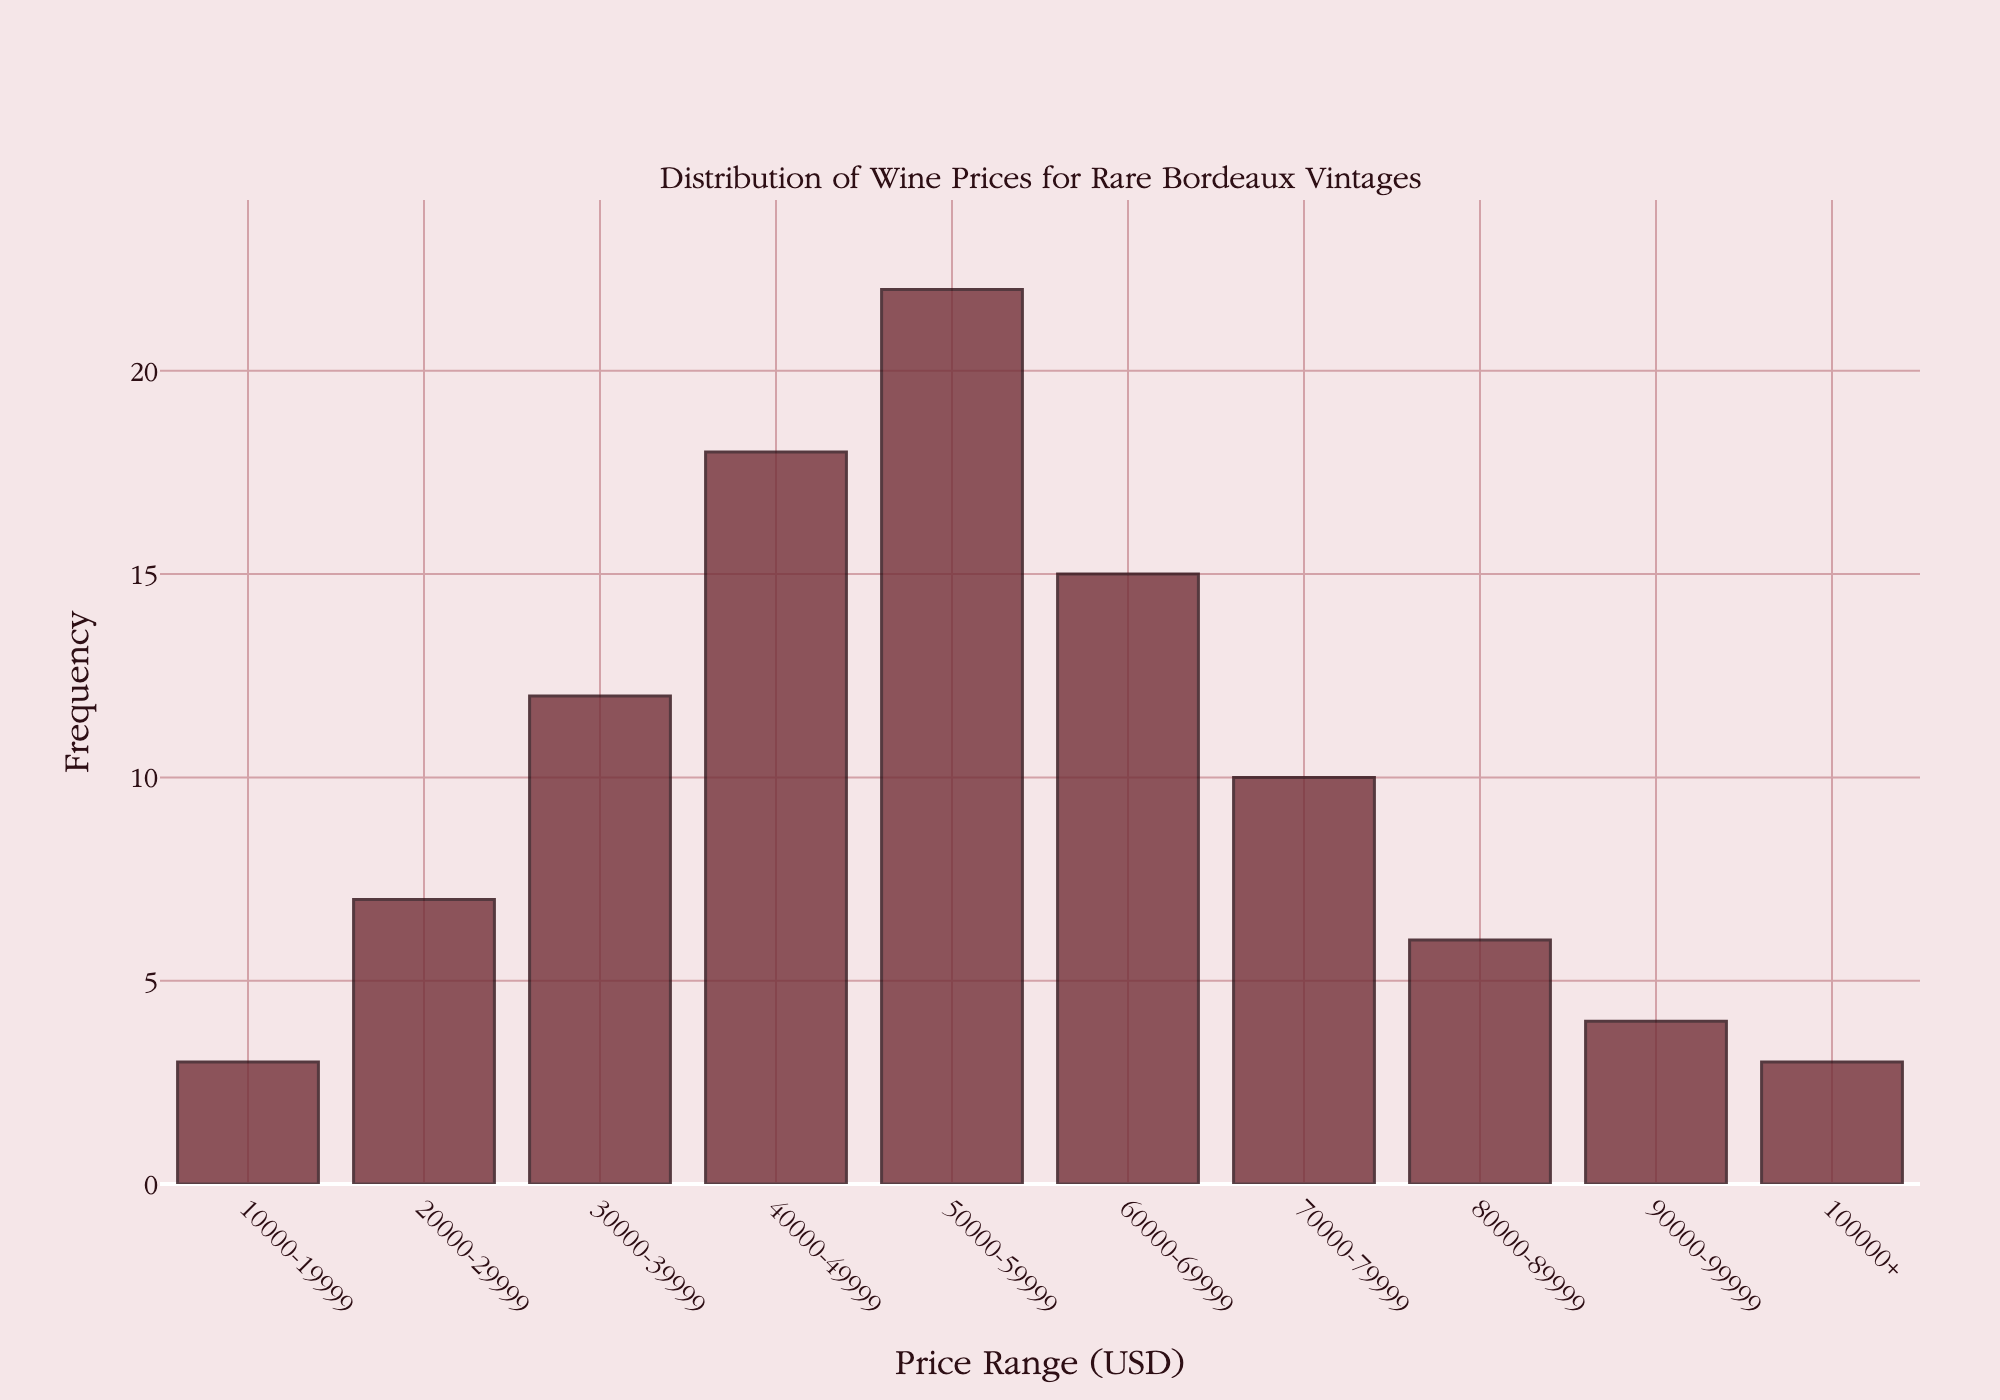What's the color of the bars? By observing the figure, the bars are colored in a deep maroon shade. This is the visual element used to represent the frequency of wine prices.
Answer: Deep maroon What is the title of the plot? The title is located at the top of the plot, and it states the topic or subject of the figure.
Answer: Distribution of Wine Prices for Rare Bordeaux Vintages Which price range has the highest frequency of wines? To find this, scan the bars to identify the tallest one, which represents the range with the highest frequency.
Answer: 50000-59999 How many wines are priced between $70,000 and $79,999? Look at the bar corresponding to the price range $70,000-$79,999 and check its height.
Answer: 10 What's the difference in frequency between wines priced at $60,000-$69,999 and $30,000-$39,999? Subtract the frequency for the $30,000-$39,999 range from the frequency for the $60,000-$69,999 range.
Answer: 3 Which price range has the lowest number of wines listed? Identify the shortest bar, which represents the range with the lowest frequency. Both $10000-19999 and $100000+ ranges should be considered.
Answer: 10000-19999 and 100000+ What's the total number of wines priced above $90,000? Sum the frequencies of the price ranges $90,000-$99,999 and $100,000+.
Answer: 7 Describe the trend you observe in the frequency of wines as the price range increases up to $60,000. Initially, there is an upward trend in frequency, peaking at $50,000-$59,999, and then it slightly decreases in the $60,000-$69,999 range.
Answer: Upward to $50,000-$59,999, then slight decrease What is the combined frequency of wines priced between $20,000 and $49,999? Add the frequencies for the price ranges $20,000-$29,999, $30,000-$39,999, and $40,000-$49,999.
Answer: 37 What visual element is used to indicate the frequency of wine prices on the y-axis? The frequency of wine prices is indicated by the height of the bars.
Answer: Height of the bars 